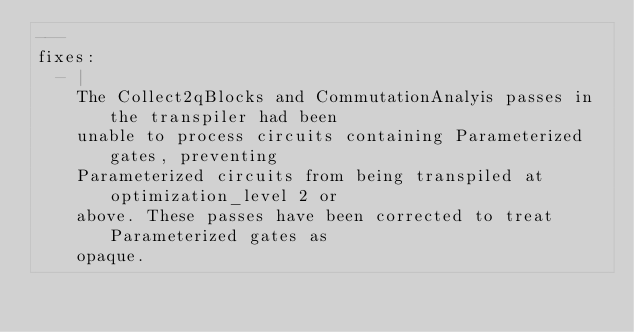<code> <loc_0><loc_0><loc_500><loc_500><_YAML_>---
fixes:
  - |
    The Collect2qBlocks and CommutationAnalyis passes in the transpiler had been
    unable to process circuits containing Parameterized gates, preventing
    Parameterized circuits from being transpiled at optimization_level 2 or
    above. These passes have been corrected to treat Parameterized gates as
    opaque.
    
</code> 